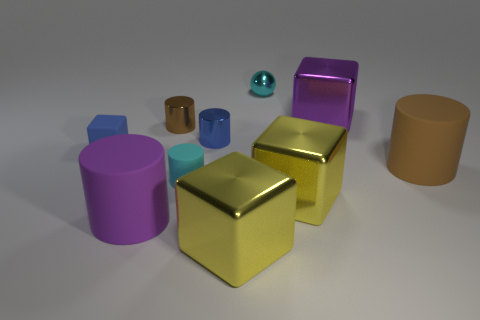Are there any other things that have the same shape as the tiny cyan shiny object?
Provide a short and direct response. No. There is a block that is behind the big purple rubber thing and in front of the small blue rubber cube; what size is it?
Your response must be concise. Large. There is a matte cube; is it the same color as the small cylinder that is right of the cyan cylinder?
Give a very brief answer. Yes. Are there any large matte objects that have the same shape as the brown shiny thing?
Your answer should be very brief. Yes. How many things are cyan things or big cubes in front of the small matte cylinder?
Your answer should be very brief. 4. What number of other objects are there of the same material as the tiny cyan sphere?
Offer a very short reply. 5. What number of things are large brown matte things or purple shiny things?
Give a very brief answer. 2. Are there more brown objects that are behind the brown matte cylinder than big rubber things on the left side of the big purple matte thing?
Give a very brief answer. Yes. There is a big rubber object that is in front of the large brown matte object; does it have the same color as the tiny cylinder on the left side of the cyan cylinder?
Give a very brief answer. No. How big is the yellow metal block that is right of the small cyan metallic sphere that is behind the purple object in front of the purple cube?
Your answer should be compact. Large. 